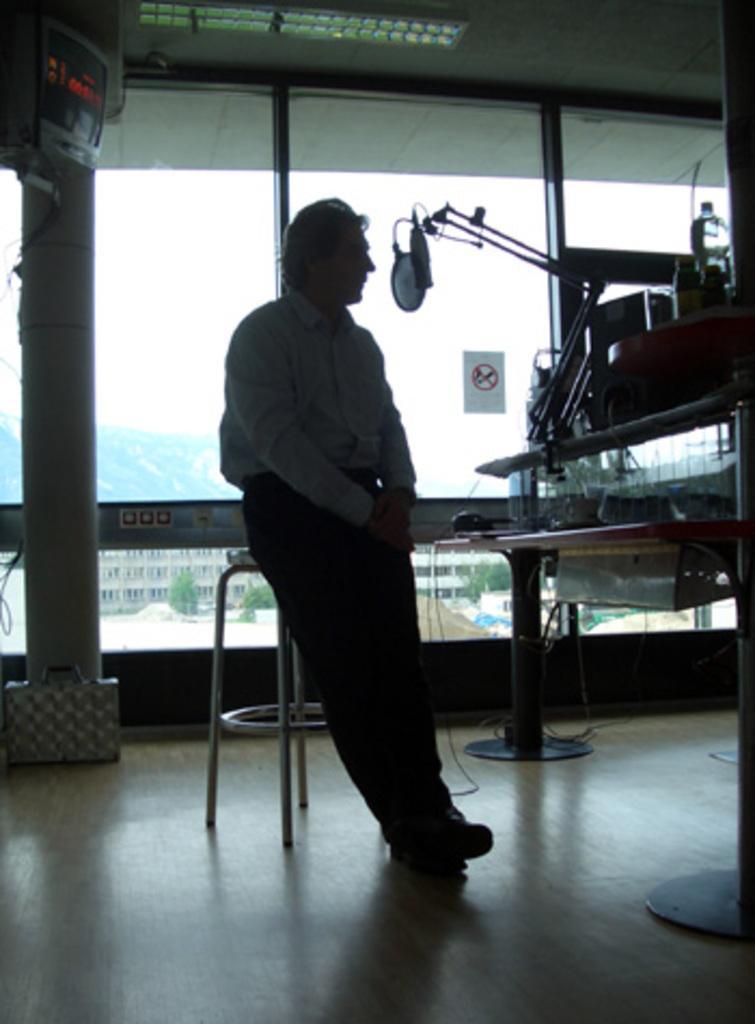Please provide a concise description of this image. In the center of the picture there is a person sitting on a stool. On the right there are bottle, microphone, cables and other objects. On the left there are briefcase, cables, television and pillar. In the center of the picture there is a window, outside the window there are buildings, trees, and hill. 